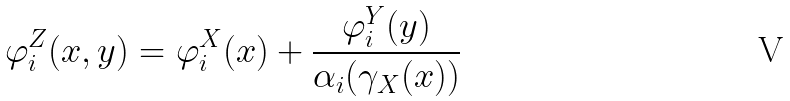Convert formula to latex. <formula><loc_0><loc_0><loc_500><loc_500>\varphi _ { i } ^ { Z } ( x , y ) = \varphi _ { i } ^ { X } ( x ) + \frac { \varphi _ { i } ^ { Y } ( y ) } { \alpha _ { i } ( \gamma _ { X } ( x ) ) }</formula> 